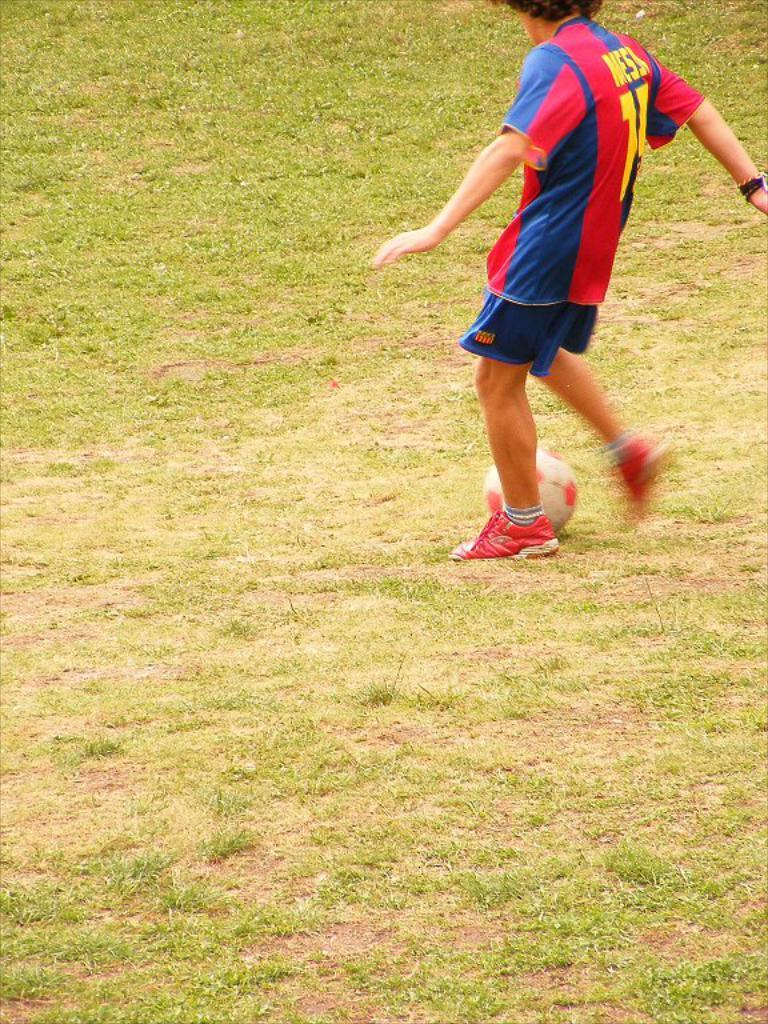What is the main subject of the image? There is a person standing in the image. Where is the person standing? The person is standing on the ground. What type of vegetation can be seen in the image? There is grass visible in the image. What object is on the ground in the image? There is a ball on the ground in the image. What type of development is taking place in the field shown in the image? There is no field present in the image, and therefore no development can be observed. How much zinc is present in the ball shown in the image? There is no information about the composition of the ball, so we cannot determine the amount of zinc present. 